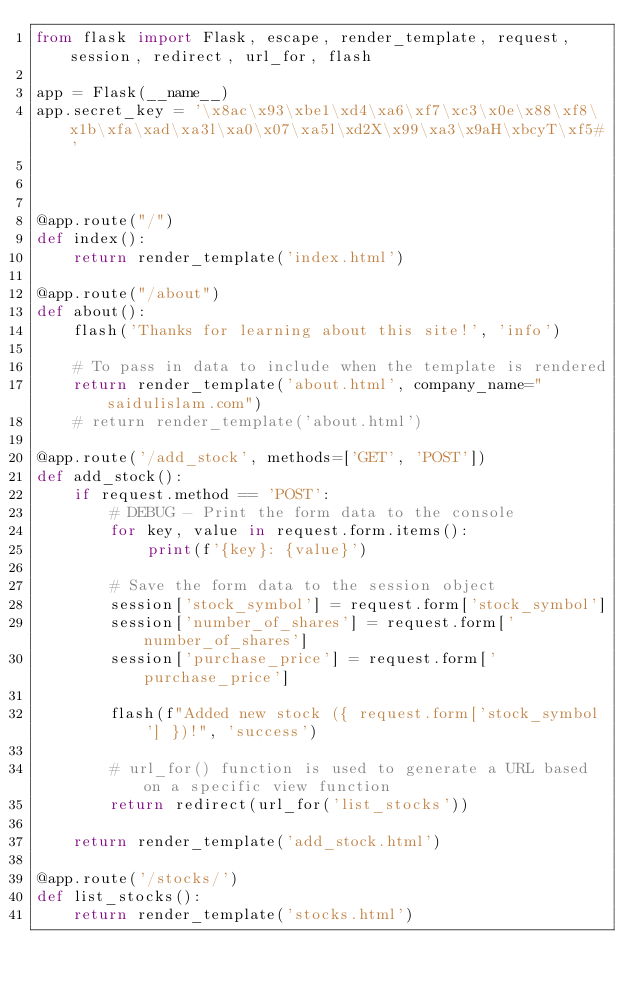Convert code to text. <code><loc_0><loc_0><loc_500><loc_500><_Python_>from flask import Flask, escape, render_template, request, session, redirect, url_for, flash

app = Flask(__name__)
app.secret_key = '\x8ac\x93\xbe1\xd4\xa6\xf7\xc3\x0e\x88\xf8\x1b\xfa\xad\xa3l\xa0\x07\xa5l\xd2X\x99\xa3\x9aH\xbcyT\xf5#'



@app.route("/")
def index():
    return render_template('index.html')

@app.route("/about")
def about():
    flash('Thanks for learning about this site!', 'info')
    
    # To pass in data to include when the template is rendered
    return render_template('about.html', company_name="saidulislam.com")
    # return render_template('about.html')

@app.route('/add_stock', methods=['GET', 'POST'])
def add_stock():
    if request.method == 'POST':
        # DEBUG - Print the form data to the console
        for key, value in request.form.items():
            print(f'{key}: {value}')

        # Save the form data to the session object
        session['stock_symbol'] = request.form['stock_symbol']
        session['number_of_shares'] = request.form['number_of_shares']
        session['purchase_price'] = request.form['purchase_price']

        flash(f"Added new stock ({ request.form['stock_symbol'] })!", 'success')

        # url_for() function is used to generate a URL based on a specific view function 
        return redirect(url_for('list_stocks')) 

    return render_template('add_stock.html')

@app.route('/stocks/')
def list_stocks():
    return render_template('stocks.html')</code> 